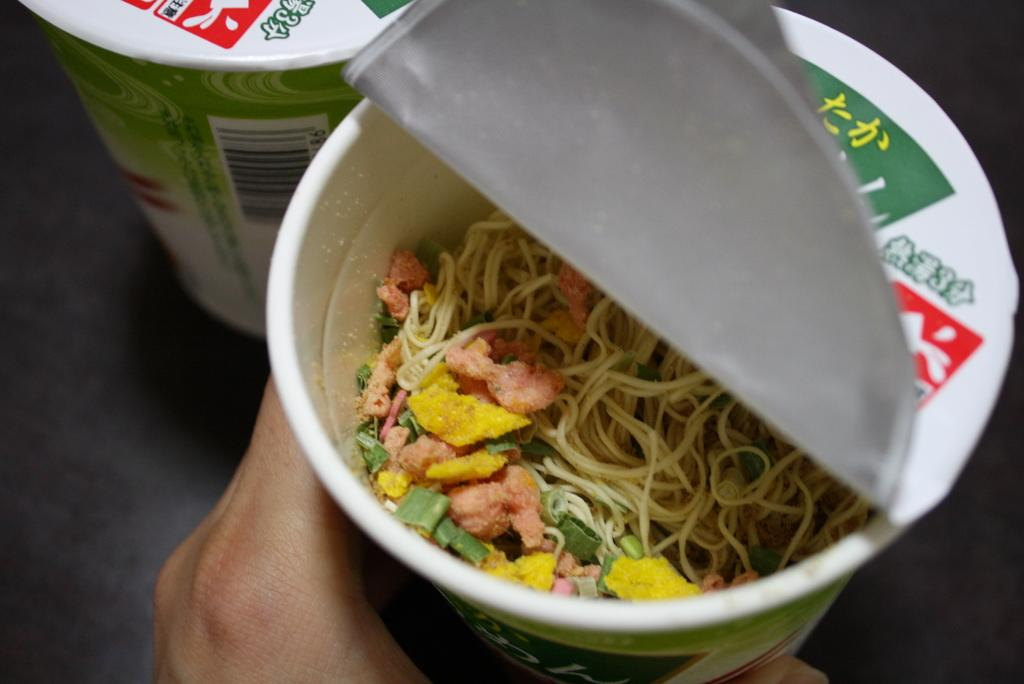Who or what is present in the image? There is a person in the image. What is the person doing in the image? The person is holding an object. What can be found inside the object the person is holding? There are food items in the object. What can be seen beneath the person and object in the image? The ground is visible in the image. What type of oil is being used to lubricate the lift in the image? There is no lift or oil present in the image; it features a person holding an object with food items. 